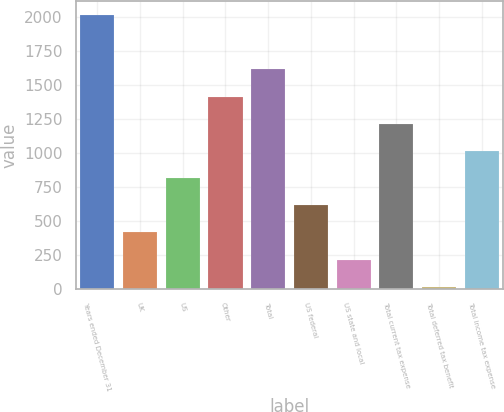Convert chart. <chart><loc_0><loc_0><loc_500><loc_500><bar_chart><fcel>Years ended December 31<fcel>UK<fcel>US<fcel>Other<fcel>Total<fcel>US federal<fcel>US state and local<fcel>Total current tax expense<fcel>Total deferred tax benefit<fcel>Total income tax expense<nl><fcel>2013<fcel>413.8<fcel>813.6<fcel>1413.3<fcel>1613.2<fcel>613.7<fcel>213.9<fcel>1213.4<fcel>14<fcel>1013.5<nl></chart> 